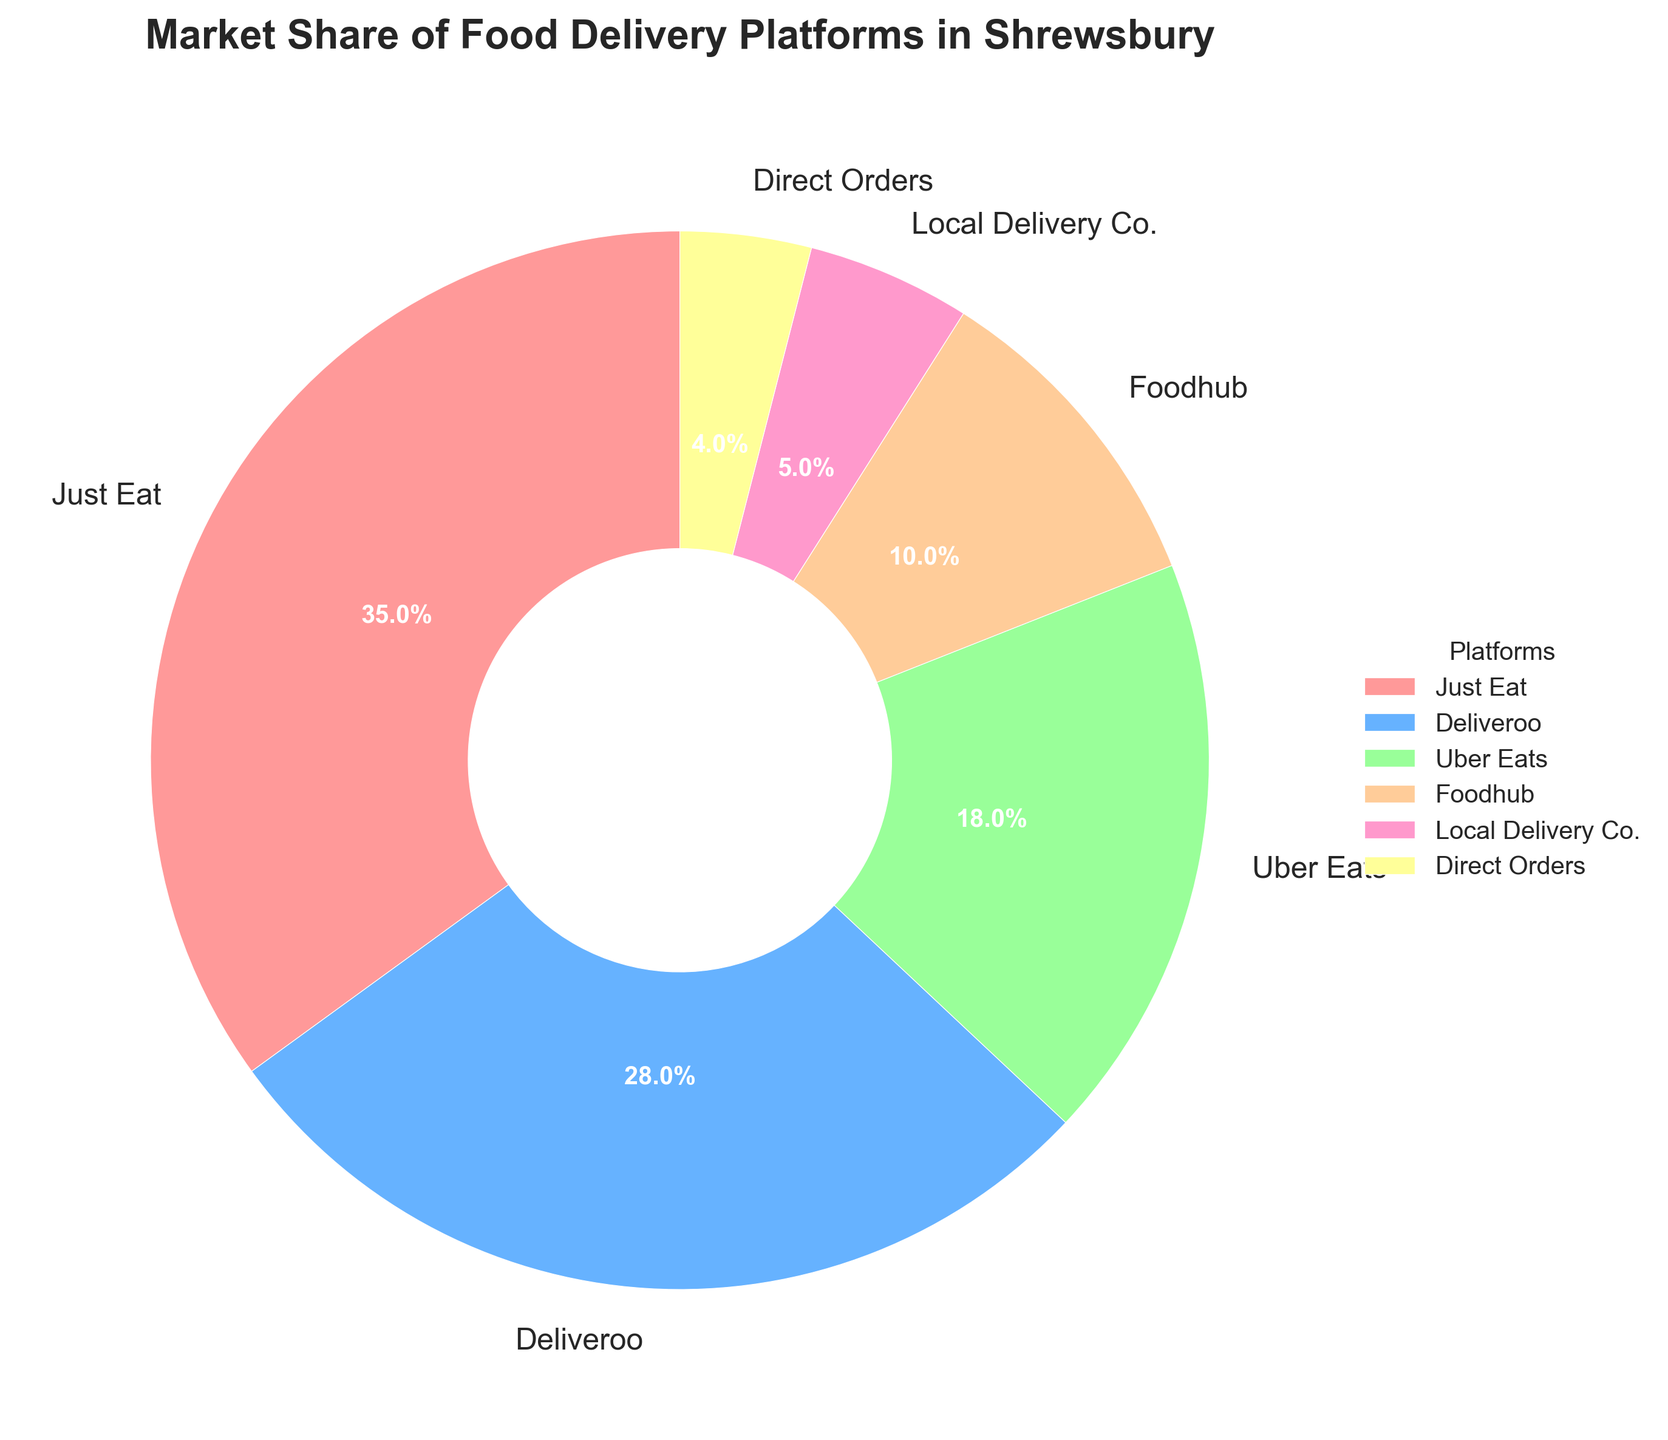What is the market share percentage of Just Eat? The figure shows a pie chart with each segment representing the market share of different platforms. The segment labeled "Just Eat" covers 35% of the market.
Answer: 35% Which platform has a larger market share, Deliveroo or Uber Eats? By comparing the two segments, Deliveroo covers a larger portion of the pie chart at 28%, while Uber Eats covers less at 18%.
Answer: Deliveroo What is the combined market share of Foodhub and Local Delivery Co.? Add the market shares of Foodhub (10%) and Local Delivery Co. (5%) to get the combined share. 10% + 5% = 15%
Answer: 15% Which platform has the smallest market share, and what is its percentage? Among the segments displayed, the smallest slice represents Direct Orders, which has a market share of 4%.
Answer: Direct Orders, 4% How much larger is the market share of Just Eat compared to Direct Orders? Subtract the market share of Direct Orders (4%) from that of Just Eat (35%). 35% - 4% = 31%
Answer: 31% What is the difference in market share between Deliveroo and Uber Eats? Subtract the market share of Uber Eats (18%) from that of Deliveroo (28%). 28% - 18% = 10%
Answer: 10% Which platforms have a combined market share equal to or greater than Just Eat alone? Just Eat has a market share of 35%. By examining combinations, we find that Deliveroo (28%) + Uber Eats (18%) = 46%, which is greater, and Deliveroo (28%) + Foodhub (10%) = 38%, which is also greater.
Answer: Deliveroo + Uber Eats, Deliveroo + Foodhub Which color represents the Local Delivery Co. segment? The Local Delivery Co. segment is represented by a color in the pie chart. The visual inspection shows it to be pink.
Answer: pink 